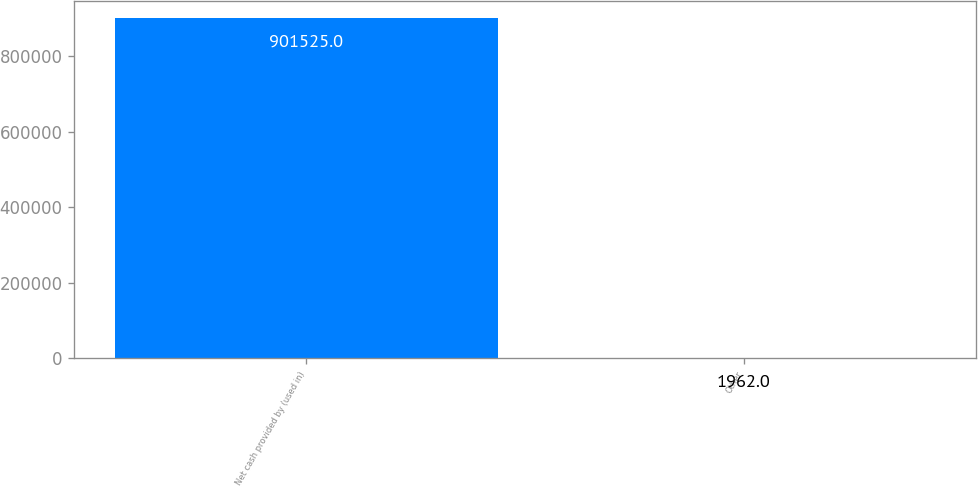<chart> <loc_0><loc_0><loc_500><loc_500><bar_chart><fcel>Net cash provided by (used in)<fcel>Other<nl><fcel>901525<fcel>1962<nl></chart> 